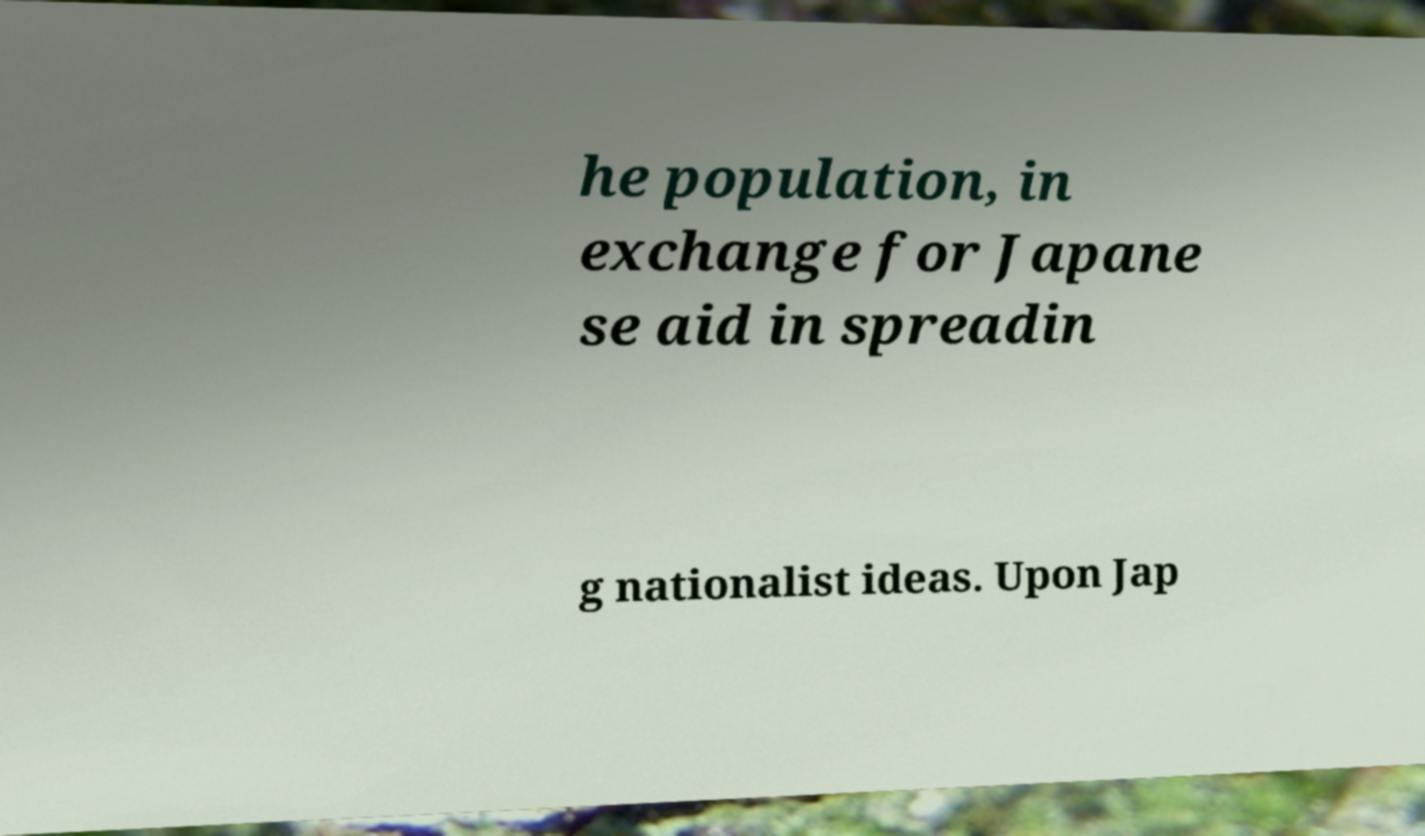Could you extract and type out the text from this image? he population, in exchange for Japane se aid in spreadin g nationalist ideas. Upon Jap 